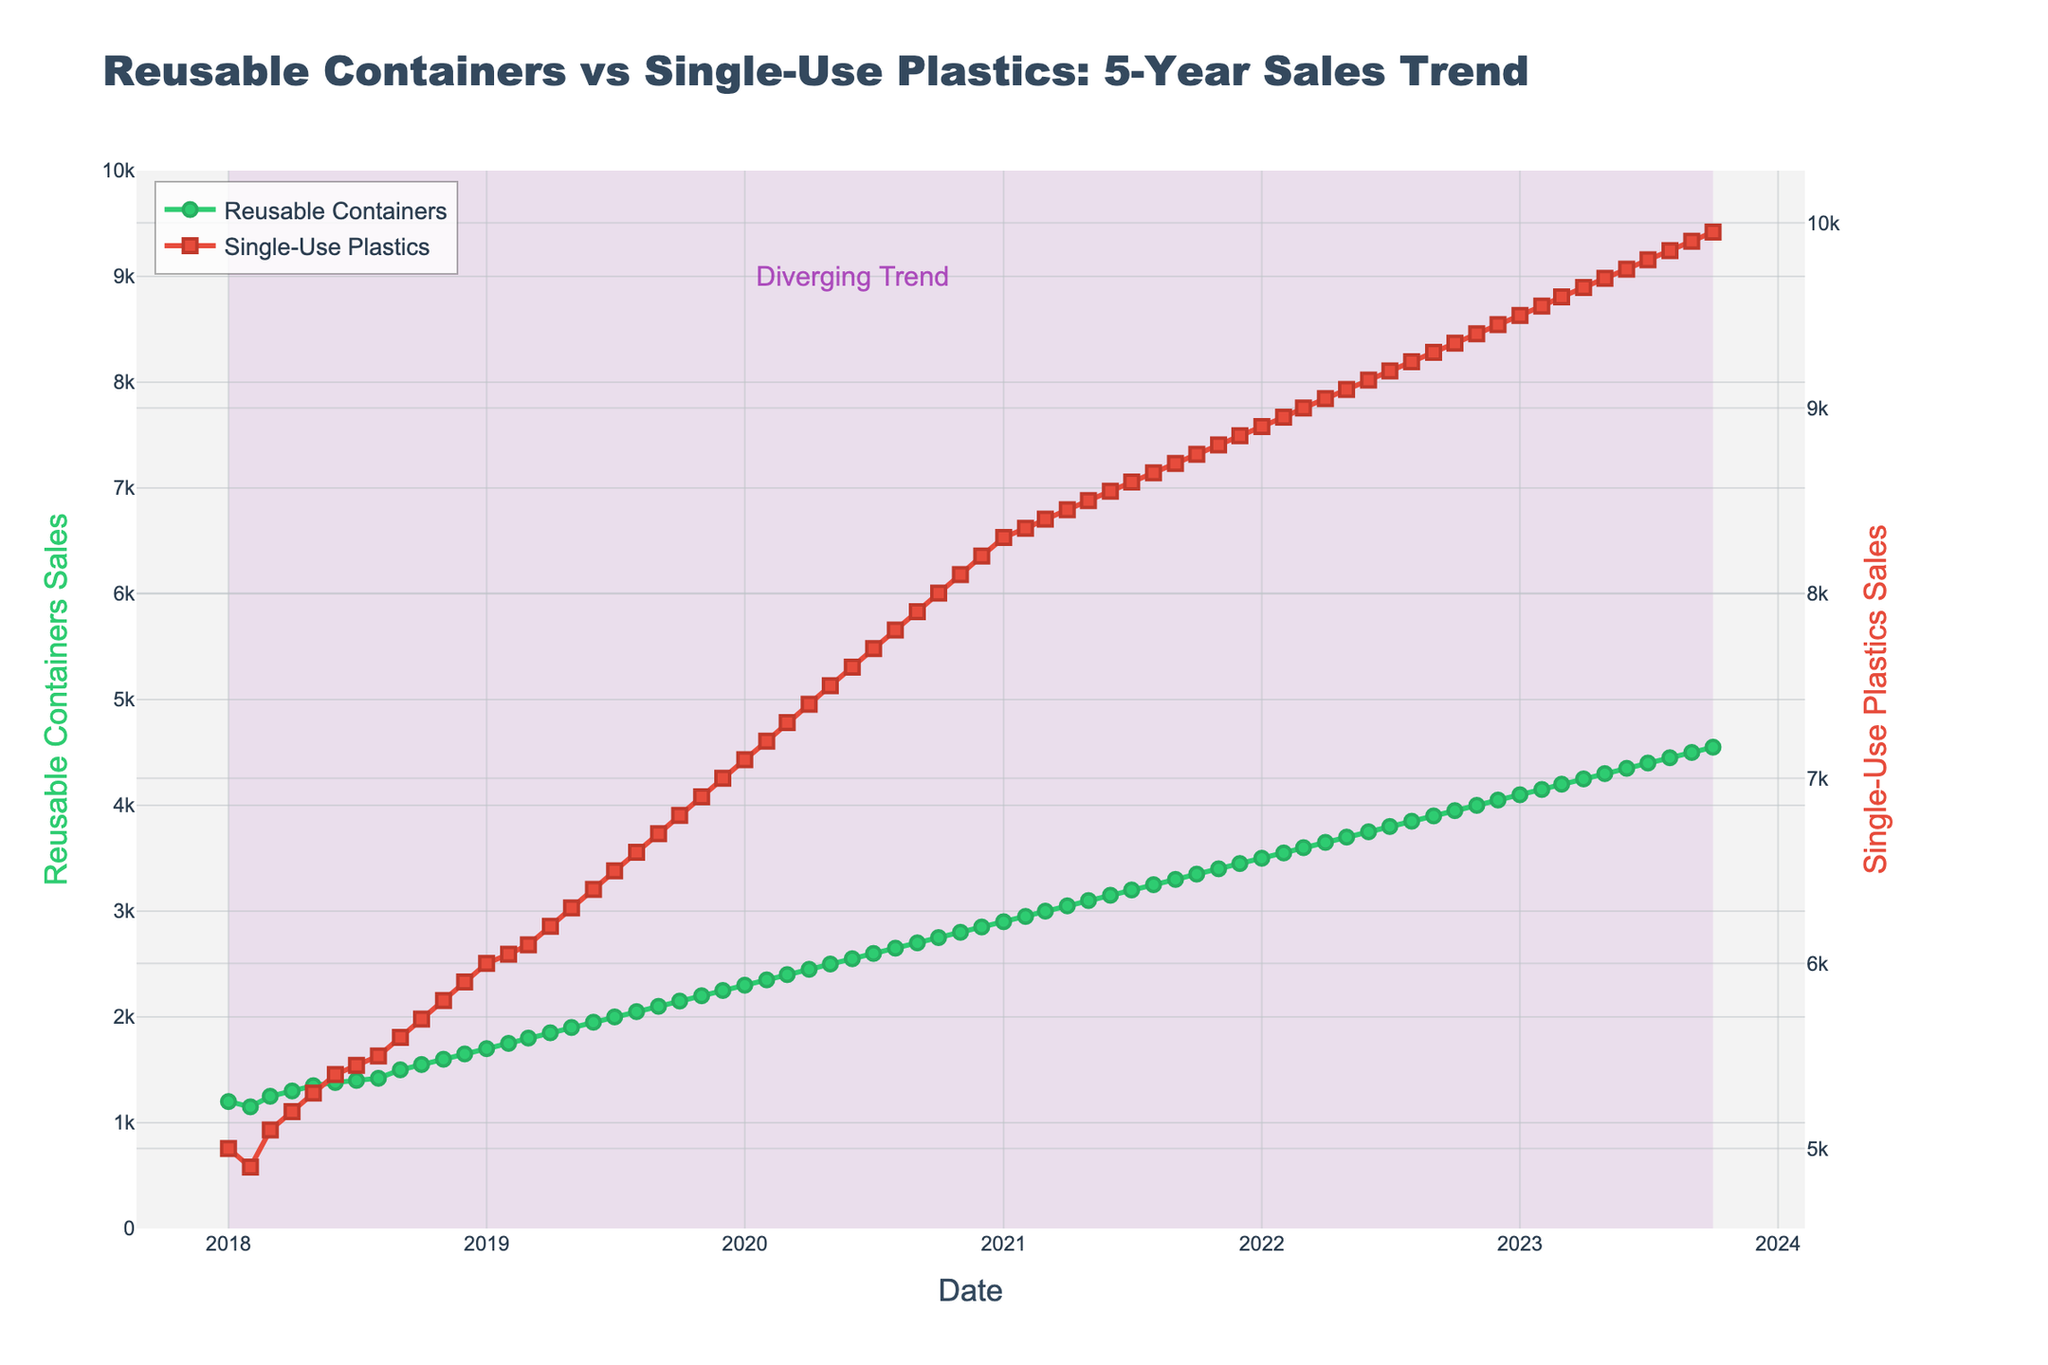What is the title of the figure? The title of the figure is prominently displayed at the top of the plot.
Answer: Reusable Containers vs Single-Use Plastics: 5-Year Sales Trend How many data points are there for Reusable Containers? We can count the number of data points on the line for Reusable Containers. There is one data point per month over a 5-year period, so 60 months in total.
Answer: 60 Which product experienced a higher growth in sales from January 2018 to October 2023? Compare the initial and final sales values for both Reusable Containers and Single-Use Plastics. Reusable Containers grew from 1200 to 4550, and Single-Use Plastics grew from 5000 to 9950. Calculate the difference (4550 - 1200 = 3350 for Reusable Containers, and 9950 - 5000 = 4950 for Single-Use Plastics). Single-Use Plastics had a higher increase.
Answer: Single-Use Plastics Between which years can we observe a noticeable increase in the sales of Reusable Containers? By observing the slope of the Reusable Containers line, the period with a noticeable steeper increase indicates a higher growth rate. The line becomes steeper from 2020 onwards.
Answer: 2020-2023 What is the approximate sales value of Single-Use Plastics in January 2021? Locate the data point corresponding to January 2021 on the Single-Use Plastics line. The y-axis value can be read off around 8300.
Answer: 8300 When do the sales of Reusable Containers reach 3000 for the first time? Look for the data point on the Reusable Containers line where the value first reaches 3000. This occurs around March 2021.
Answer: March 2021 What is the color used for the Reusable Containers line? The Reusable Containers line is represented by a green color.
Answer: Green How does the sales trend of Single-Use Plastics compare to that of Reusable Containers over the 5-year period? Observe the general direction and slope of both lines. Single-Use Plastics show a consistent increase, while Reusable Containers also increase but at a slightly slower rate.
Answer: Both increasing, Single-Use Plastics faster Which month and year show the largest sales value for Single-Use Plastics? The end of the data series represents the latest data point, which has the highest sales value for Single-Use Plastics in the dataset.
Answer: October 2023 